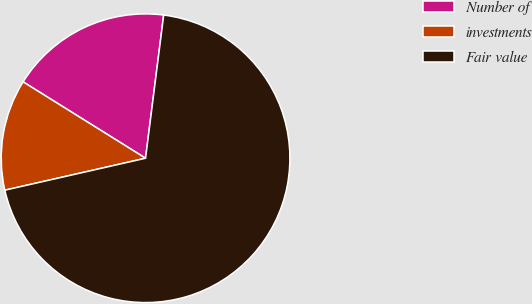<chart> <loc_0><loc_0><loc_500><loc_500><pie_chart><fcel>Number of<fcel>investments<fcel>Fair value<nl><fcel>18.13%<fcel>12.43%<fcel>69.44%<nl></chart> 